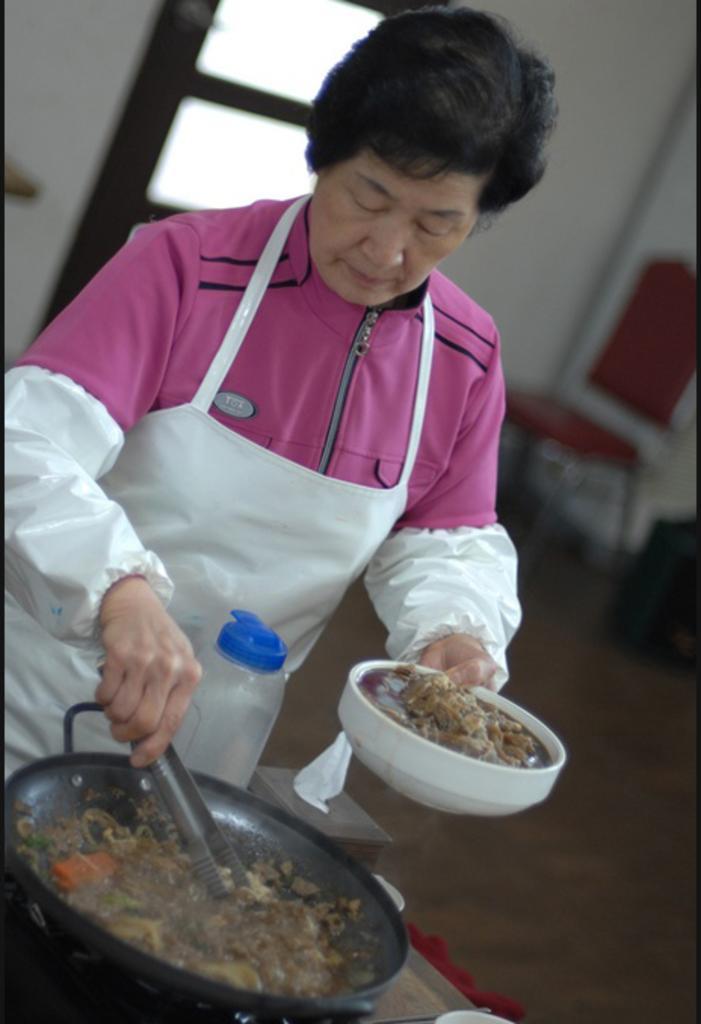Could you give a brief overview of what you see in this image? In this picture a woman with a jacket seems like cooking holding a bowl in her hand and some food in the pan. In the background i could see a window and a wall and a chair. 